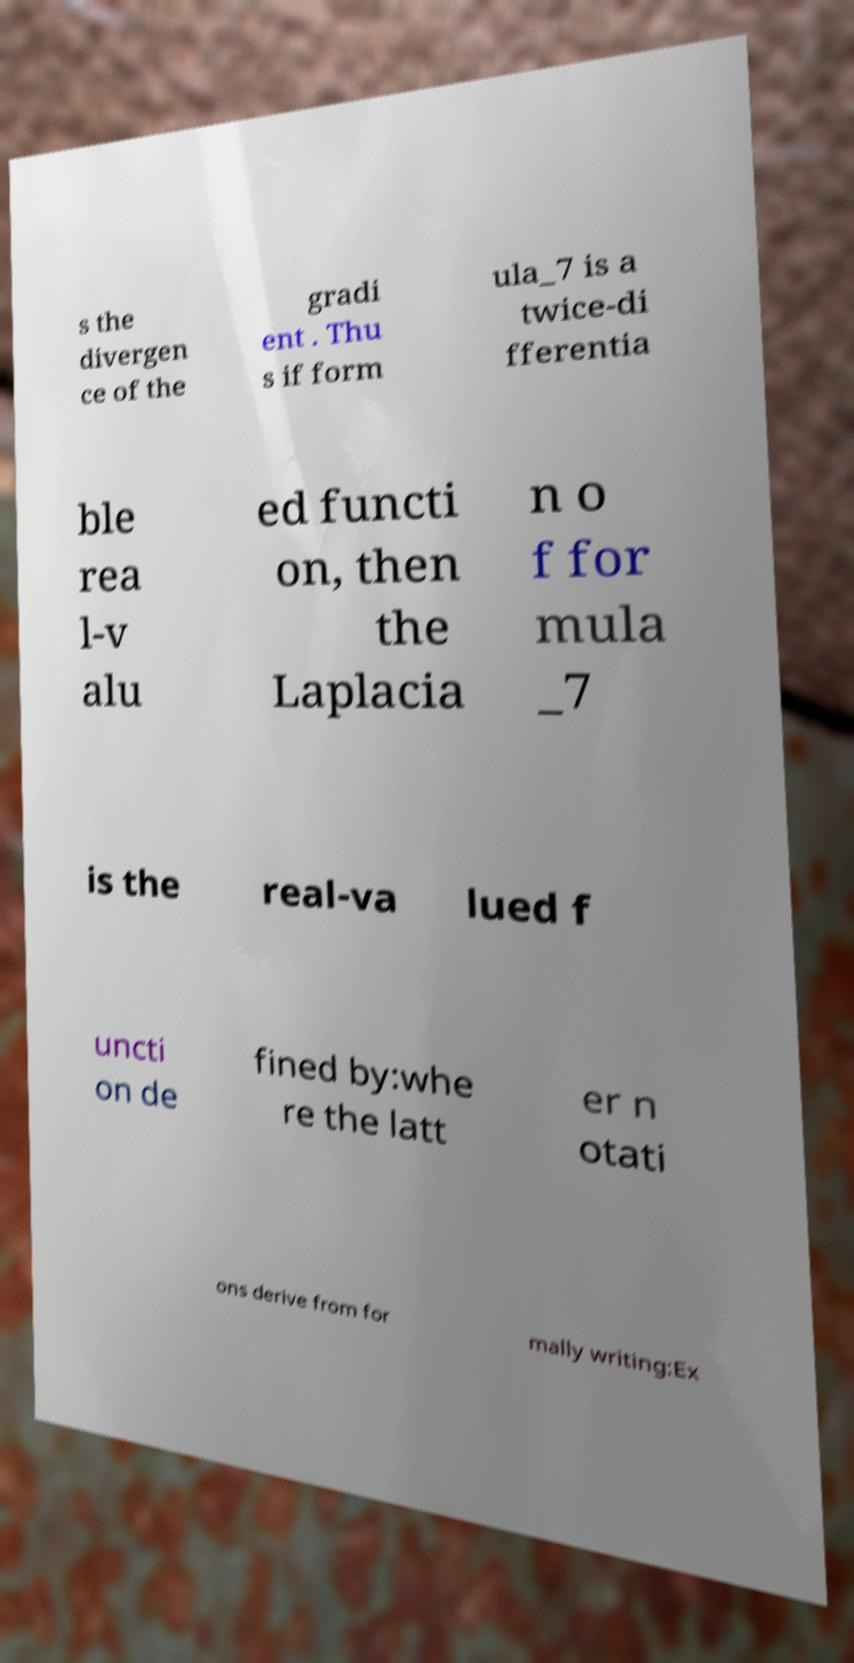Please identify and transcribe the text found in this image. s the divergen ce of the gradi ent . Thu s if form ula_7 is a twice-di fferentia ble rea l-v alu ed functi on, then the Laplacia n o f for mula _7 is the real-va lued f uncti on de fined by:whe re the latt er n otati ons derive from for mally writing:Ex 